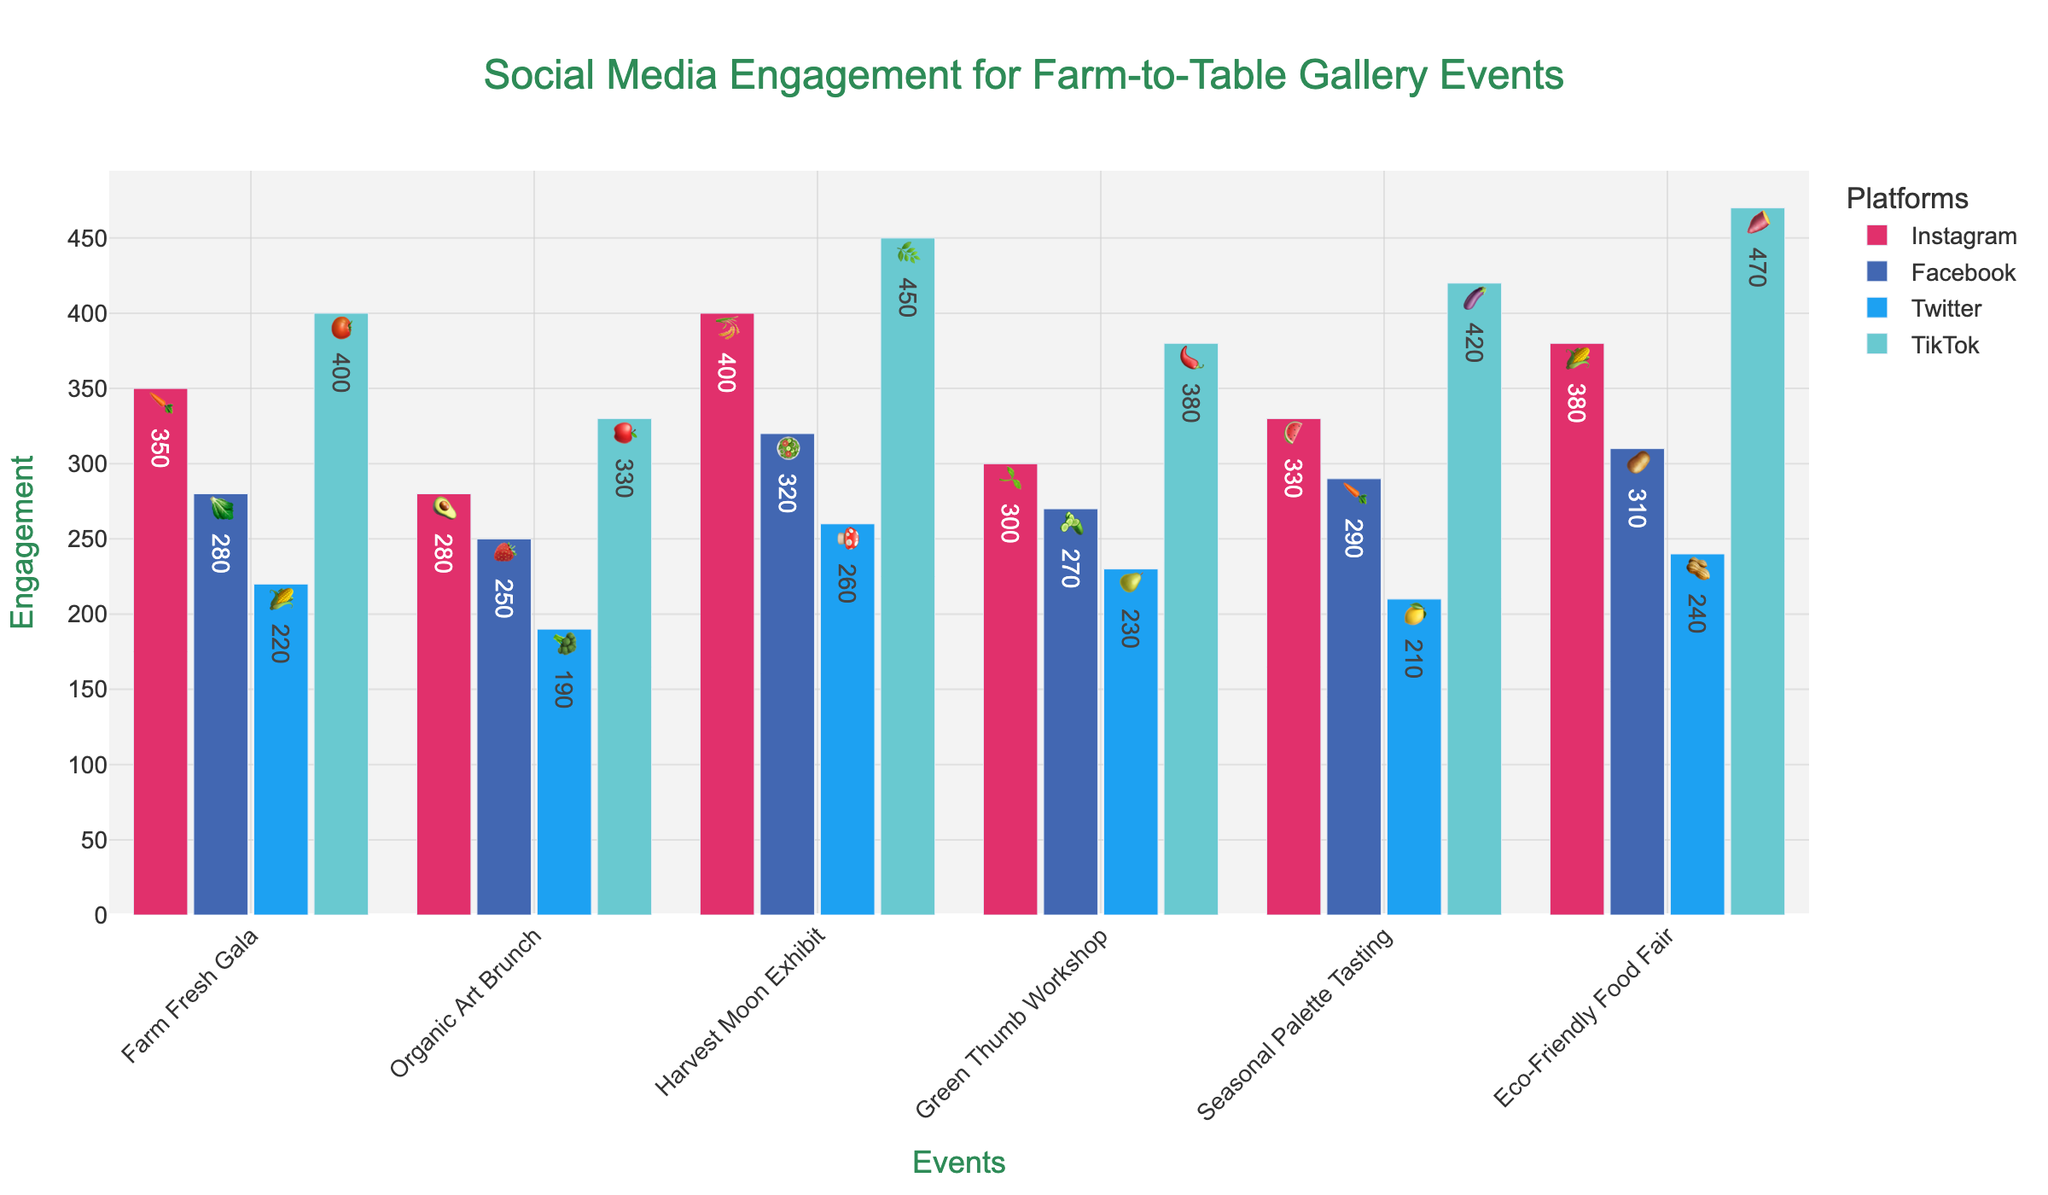What's the overall most engaging event on TikTok? The TikTok bar with the highest value should be identified. The Harvest Moon Exhibit has the highest engagement on TikTok with 450.
Answer: Harvest Moon Exhibit Which social media platform had the highest engagement for the Farm Fresh Gala event? Examine the values for each platform for the Farm Fresh Gala event. TikTok had the highest engagement with a value of 400.
Answer: TikTok How does Instagram engagement for the Green Thumb Workshop compare to Twitter engagement for the Organic Art Brunch? Find the values: Instagram (300) for Green Thumb Workshop and Twitter (190) for Organic Art Brunch. Compare them: 300 is greater than 190.
Answer: Instagram > Twitter What's the total social media engagement for the Seasonal Palette Tasting event across all platforms? Sum the values for Instagram (330), Facebook (290), Twitter (210), and TikTok (420): 330 + 290 + 210 + 420 = 1250.
Answer: 1250 Between Instagram and Facebook, which platform had more engagement on average across all events? Calculate the average engagement for each platform. Instagram: (350+280+400+300+330+380)/6 = 340; Facebook: (280+250+320+270+290+310)/6 ≈ 286.67. Compare: Instagram has a higher average.
Answer: Instagram For the Eco-Friendly Food Fair, is the difference in engagement between Instagram and Twitter larger than 100? Calculate the difference: Instagram (380) - Twitter (240) = 140. Since 140 > 100, the difference is larger than 100.
Answer: Yes Which event had the least engagement on any platform? Identify the lowest value across all events and platforms. Twitter engagement for the Seasonal Palette Tasting is the lowest at 210.
Answer: Seasonal Palette Tasting (Twitter) What is the combined engagement of Instagram and TikTok for the Harvest Moon Exhibit? Sum the values for Instagram (400) and TikTok (450): 400 + 450 = 850.
Answer: 850 Which event had a higher Facebook engagement than Instagram engagement? Compare the values for each event for Facebook and Instagram. No event had higher Facebook engagement than Instagram.
Answer: None Are there any events where the TikTok engagement exceeds the combined engagement of Facebook and Twitter? Calculate combined Facebook and Twitter for each event and compare to TikTok. Harvest Moon Exhibit TikTok (450) > Facebook (320) + Twitter (260) = 580, no event exceeds on TikTok.
Answer: None 